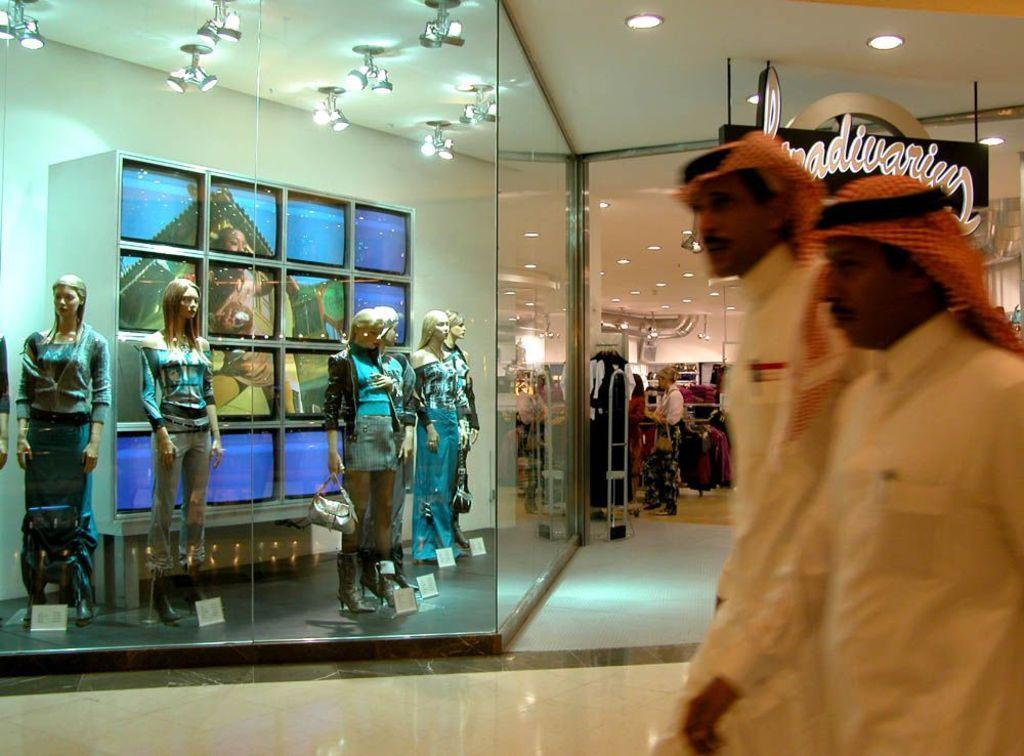In one or two sentences, can you explain what this image depicts? In this image we can see there are two people walking in front of the store behind them there is a store where we can see so many mannequins also there are so many clothes hanging on the hangers. 